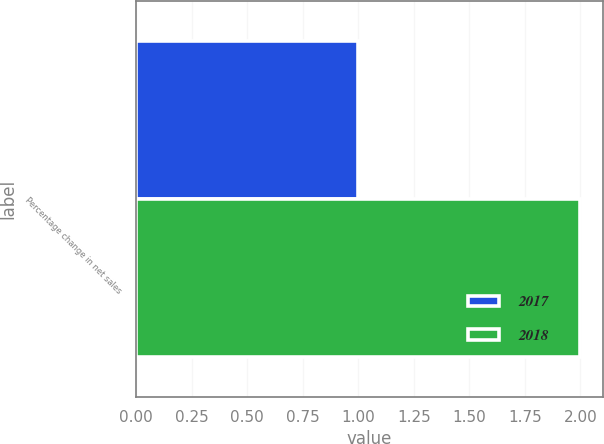Convert chart to OTSL. <chart><loc_0><loc_0><loc_500><loc_500><stacked_bar_chart><ecel><fcel>Percentage change in net sales<nl><fcel>2017<fcel>1<nl><fcel>2018<fcel>2<nl></chart> 